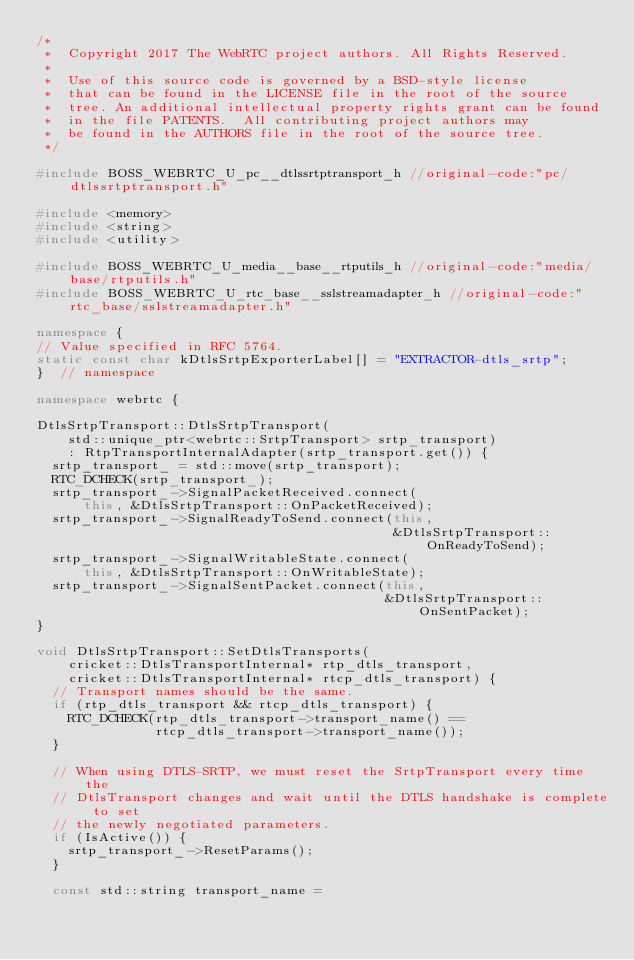Convert code to text. <code><loc_0><loc_0><loc_500><loc_500><_C++_>/*
 *  Copyright 2017 The WebRTC project authors. All Rights Reserved.
 *
 *  Use of this source code is governed by a BSD-style license
 *  that can be found in the LICENSE file in the root of the source
 *  tree. An additional intellectual property rights grant can be found
 *  in the file PATENTS.  All contributing project authors may
 *  be found in the AUTHORS file in the root of the source tree.
 */

#include BOSS_WEBRTC_U_pc__dtlssrtptransport_h //original-code:"pc/dtlssrtptransport.h"

#include <memory>
#include <string>
#include <utility>

#include BOSS_WEBRTC_U_media__base__rtputils_h //original-code:"media/base/rtputils.h"
#include BOSS_WEBRTC_U_rtc_base__sslstreamadapter_h //original-code:"rtc_base/sslstreamadapter.h"

namespace {
// Value specified in RFC 5764.
static const char kDtlsSrtpExporterLabel[] = "EXTRACTOR-dtls_srtp";
}  // namespace

namespace webrtc {

DtlsSrtpTransport::DtlsSrtpTransport(
    std::unique_ptr<webrtc::SrtpTransport> srtp_transport)
    : RtpTransportInternalAdapter(srtp_transport.get()) {
  srtp_transport_ = std::move(srtp_transport);
  RTC_DCHECK(srtp_transport_);
  srtp_transport_->SignalPacketReceived.connect(
      this, &DtlsSrtpTransport::OnPacketReceived);
  srtp_transport_->SignalReadyToSend.connect(this,
                                             &DtlsSrtpTransport::OnReadyToSend);
  srtp_transport_->SignalWritableState.connect(
      this, &DtlsSrtpTransport::OnWritableState);
  srtp_transport_->SignalSentPacket.connect(this,
                                            &DtlsSrtpTransport::OnSentPacket);
}

void DtlsSrtpTransport::SetDtlsTransports(
    cricket::DtlsTransportInternal* rtp_dtls_transport,
    cricket::DtlsTransportInternal* rtcp_dtls_transport) {
  // Transport names should be the same.
  if (rtp_dtls_transport && rtcp_dtls_transport) {
    RTC_DCHECK(rtp_dtls_transport->transport_name() ==
               rtcp_dtls_transport->transport_name());
  }

  // When using DTLS-SRTP, we must reset the SrtpTransport every time the
  // DtlsTransport changes and wait until the DTLS handshake is complete to set
  // the newly negotiated parameters.
  if (IsActive()) {
    srtp_transport_->ResetParams();
  }

  const std::string transport_name =</code> 